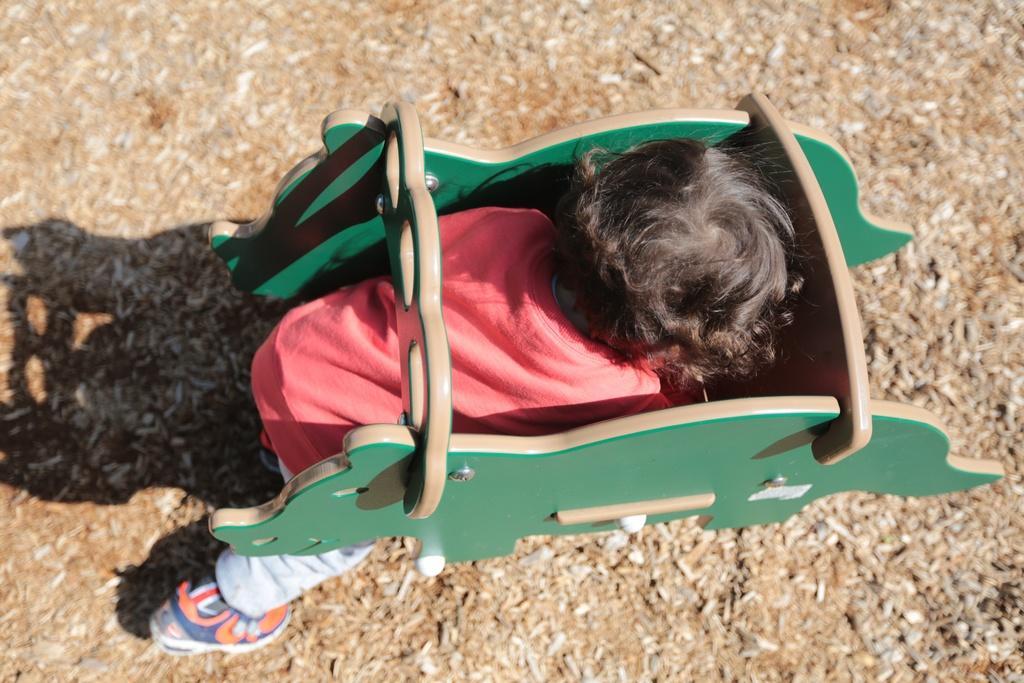Describe this image in one or two sentences. Here in this picture we can see a child trying to sit on the wooden toy, which is present on the ground. 